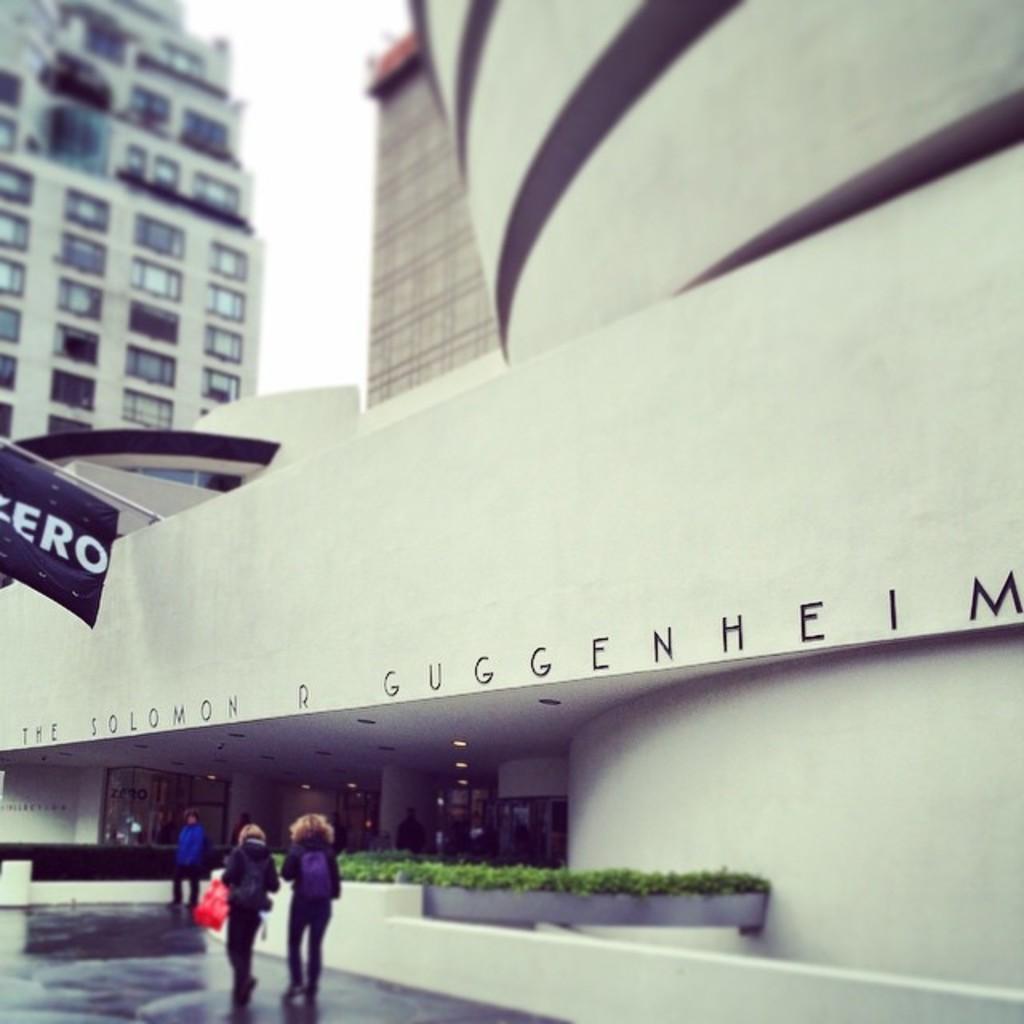Could you give a brief overview of what you see in this image? As we can see in the image there are buildings, banner, windows, plants, few people walking and at the top there is sky. 